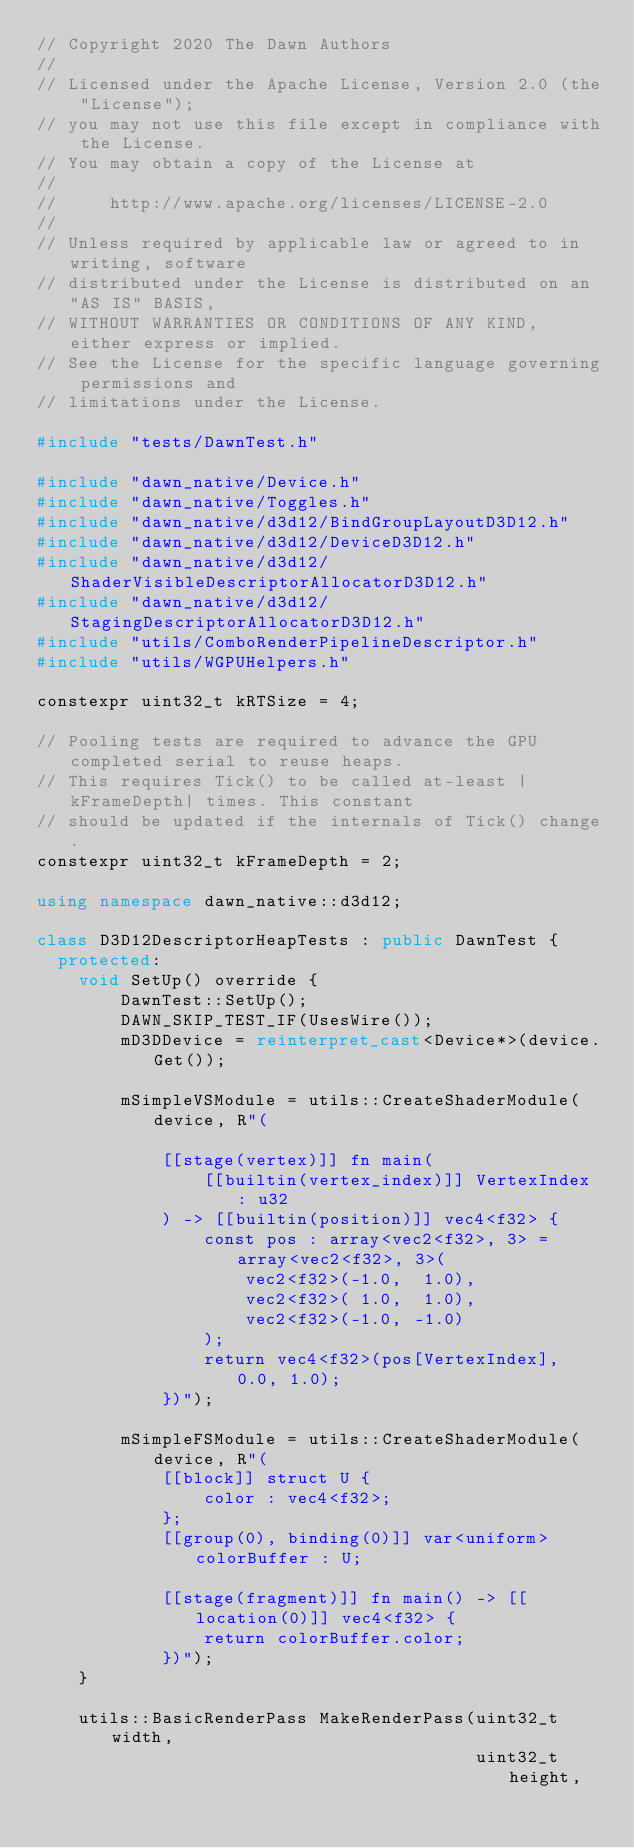<code> <loc_0><loc_0><loc_500><loc_500><_C++_>// Copyright 2020 The Dawn Authors
//
// Licensed under the Apache License, Version 2.0 (the "License");
// you may not use this file except in compliance with the License.
// You may obtain a copy of the License at
//
//     http://www.apache.org/licenses/LICENSE-2.0
//
// Unless required by applicable law or agreed to in writing, software
// distributed under the License is distributed on an "AS IS" BASIS,
// WITHOUT WARRANTIES OR CONDITIONS OF ANY KIND, either express or implied.
// See the License for the specific language governing permissions and
// limitations under the License.

#include "tests/DawnTest.h"

#include "dawn_native/Device.h"
#include "dawn_native/Toggles.h"
#include "dawn_native/d3d12/BindGroupLayoutD3D12.h"
#include "dawn_native/d3d12/DeviceD3D12.h"
#include "dawn_native/d3d12/ShaderVisibleDescriptorAllocatorD3D12.h"
#include "dawn_native/d3d12/StagingDescriptorAllocatorD3D12.h"
#include "utils/ComboRenderPipelineDescriptor.h"
#include "utils/WGPUHelpers.h"

constexpr uint32_t kRTSize = 4;

// Pooling tests are required to advance the GPU completed serial to reuse heaps.
// This requires Tick() to be called at-least |kFrameDepth| times. This constant
// should be updated if the internals of Tick() change.
constexpr uint32_t kFrameDepth = 2;

using namespace dawn_native::d3d12;

class D3D12DescriptorHeapTests : public DawnTest {
  protected:
    void SetUp() override {
        DawnTest::SetUp();
        DAWN_SKIP_TEST_IF(UsesWire());
        mD3DDevice = reinterpret_cast<Device*>(device.Get());

        mSimpleVSModule = utils::CreateShaderModule(device, R"(

            [[stage(vertex)]] fn main(
                [[builtin(vertex_index)]] VertexIndex : u32
            ) -> [[builtin(position)]] vec4<f32> {
                const pos : array<vec2<f32>, 3> = array<vec2<f32>, 3>(
                    vec2<f32>(-1.0,  1.0),
                    vec2<f32>( 1.0,  1.0),
                    vec2<f32>(-1.0, -1.0)
                );
                return vec4<f32>(pos[VertexIndex], 0.0, 1.0);
            })");

        mSimpleFSModule = utils::CreateShaderModule(device, R"(
            [[block]] struct U {
                color : vec4<f32>;
            };
            [[group(0), binding(0)]] var<uniform> colorBuffer : U;

            [[stage(fragment)]] fn main() -> [[location(0)]] vec4<f32> {
                return colorBuffer.color;
            })");
    }

    utils::BasicRenderPass MakeRenderPass(uint32_t width,
                                          uint32_t height,</code> 